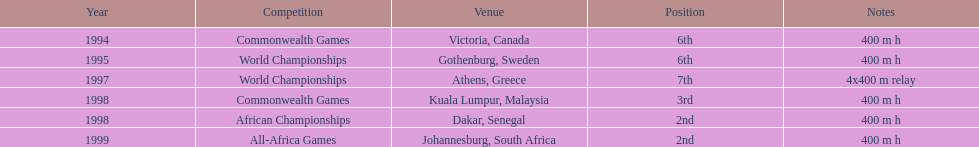Which year witnessed the highest number of competitions? 1998. 